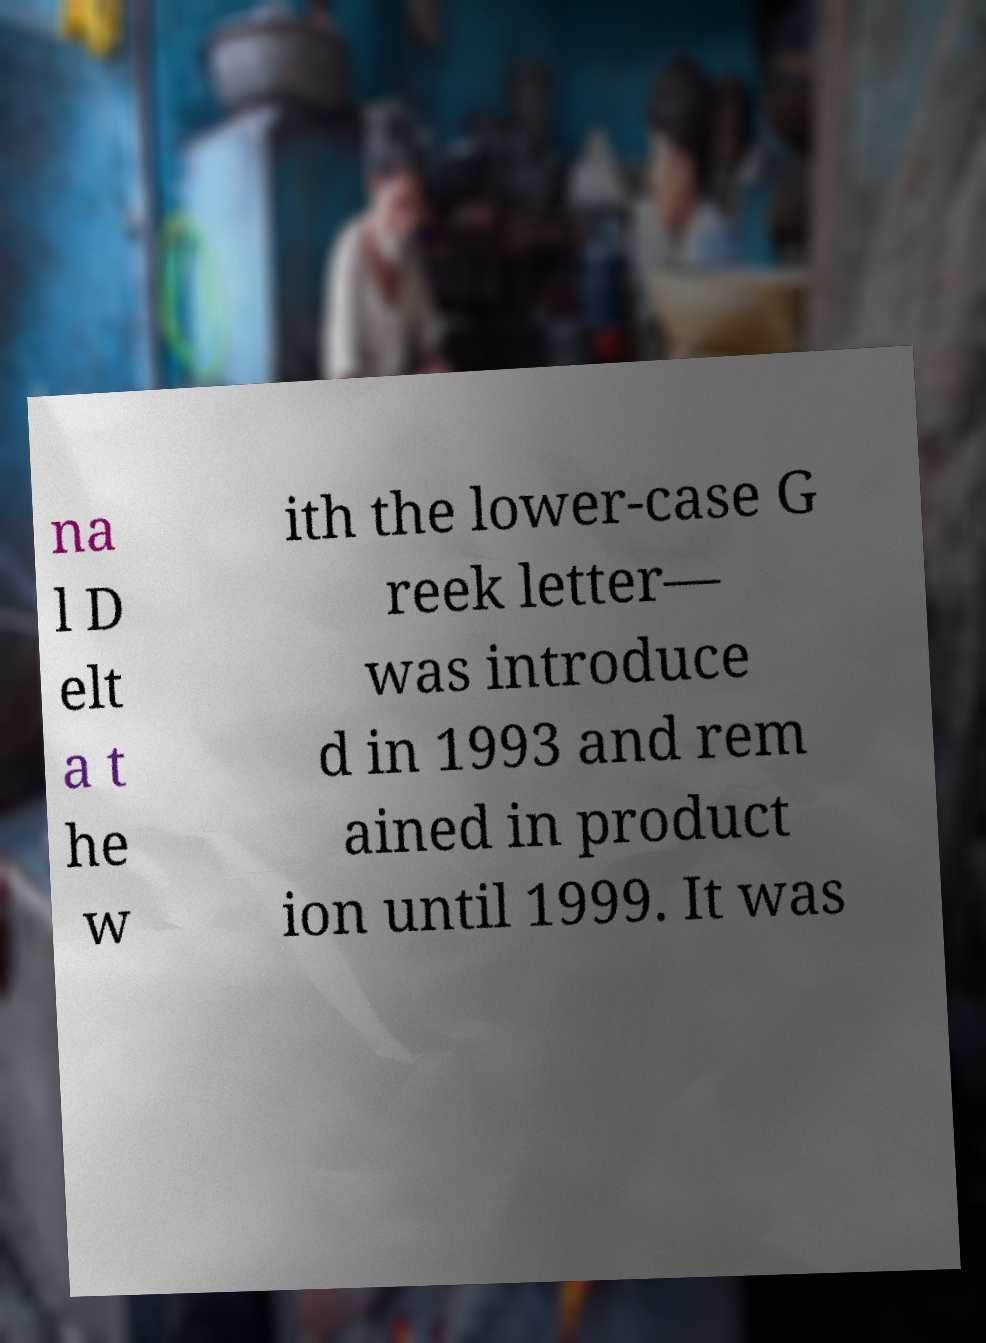There's text embedded in this image that I need extracted. Can you transcribe it verbatim? na l D elt a t he w ith the lower-case G reek letter— was introduce d in 1993 and rem ained in product ion until 1999. It was 